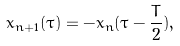Convert formula to latex. <formula><loc_0><loc_0><loc_500><loc_500>x _ { n + 1 } ( \tau ) = - x _ { n } ( \tau - \frac { T } { 2 } ) ,</formula> 